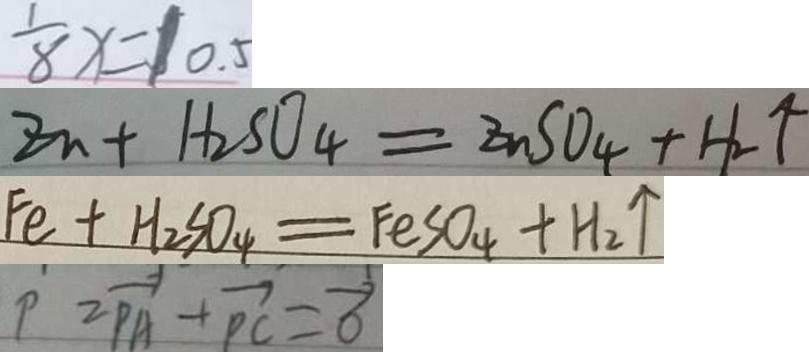Convert formula to latex. <formula><loc_0><loc_0><loc_500><loc_500>\frac { 1 } { 8 } x = 1 0 . 5 
 Z n + H _ { 2 } S O _ { 4 } = Z n S O _ { 4 } + H _ { 2 } \uparrow 
 F e + H _ { 2 } S O _ { 4 } = F e S O _ { 4 } + H _ { 2 } \uparrow 
 P = \overrightarrow { P A } + \overrightarrow { P C } = \overrightarrow { 0 }</formula> 